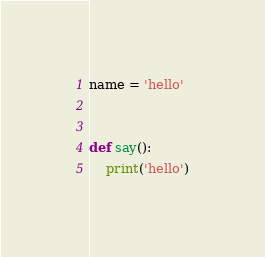Convert code to text. <code><loc_0><loc_0><loc_500><loc_500><_Python_>

name = 'hello'


def say():
    print('hello')</code> 